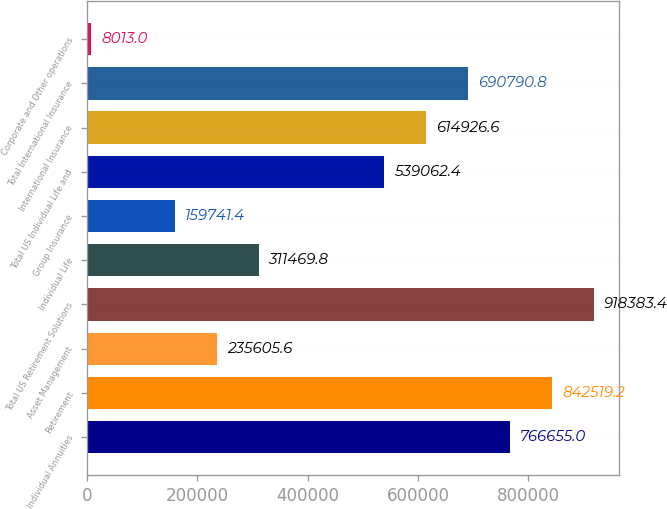Convert chart to OTSL. <chart><loc_0><loc_0><loc_500><loc_500><bar_chart><fcel>Individual Annuities<fcel>Retirement<fcel>Asset Management<fcel>Total US Retirement Solutions<fcel>Individual Life<fcel>Group Insurance<fcel>Total US Individual Life and<fcel>International Insurance<fcel>Total International Insurance<fcel>Corporate and Other operations<nl><fcel>766655<fcel>842519<fcel>235606<fcel>918383<fcel>311470<fcel>159741<fcel>539062<fcel>614927<fcel>690791<fcel>8013<nl></chart> 